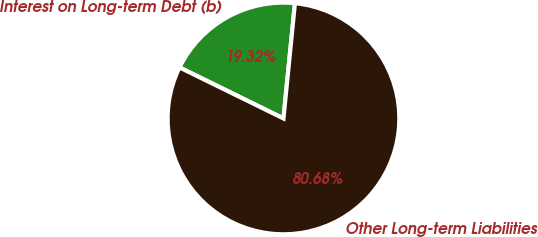Convert chart. <chart><loc_0><loc_0><loc_500><loc_500><pie_chart><fcel>Interest on Long-term Debt (b)<fcel>Other Long-term Liabilities<nl><fcel>19.32%<fcel>80.68%<nl></chart> 